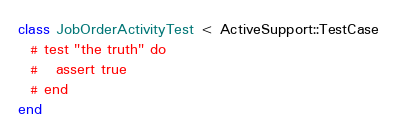<code> <loc_0><loc_0><loc_500><loc_500><_Ruby_>class JobOrderActivityTest < ActiveSupport::TestCase
  # test "the truth" do
  #   assert true
  # end
end
</code> 